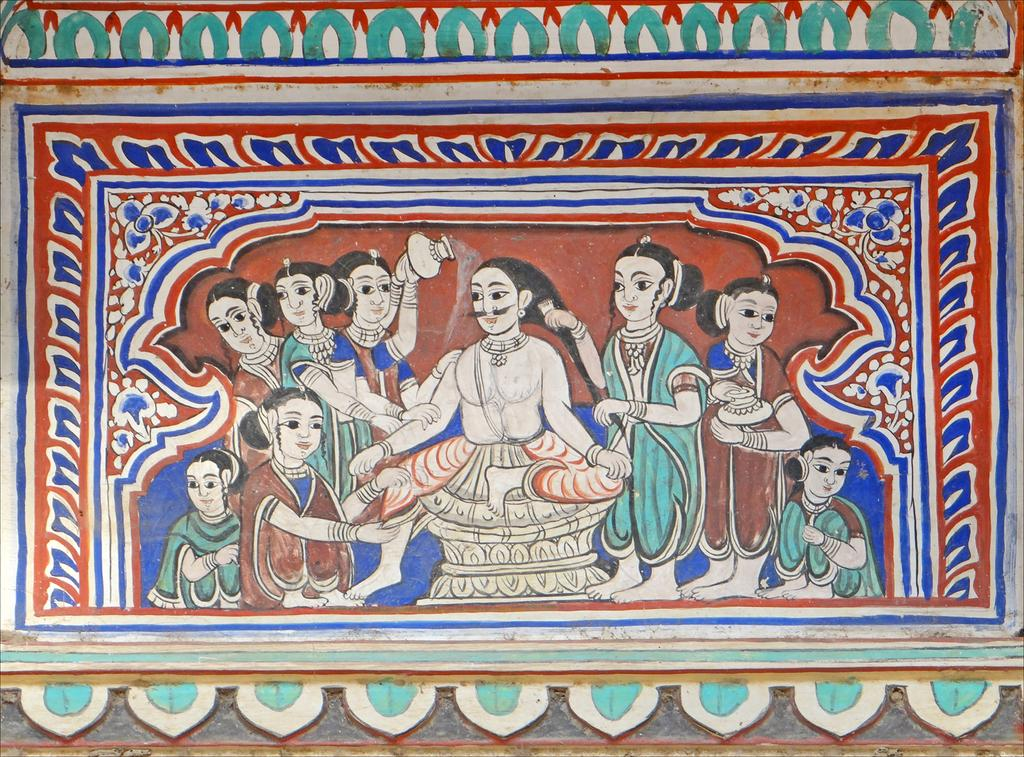What is present on the wall in the image? There is a painting on the wall in the image. Can you describe the painting? Unfortunately, the facts provided do not give any details about the painting. What is the primary color of the wall in the image? The facts provided do not specify the primary color of the wall. Where is the sister in the image? There is no mention of a sister in the image or the provided facts. What type of ball is being used in the image? There is no ball present in the image or the provided facts. 